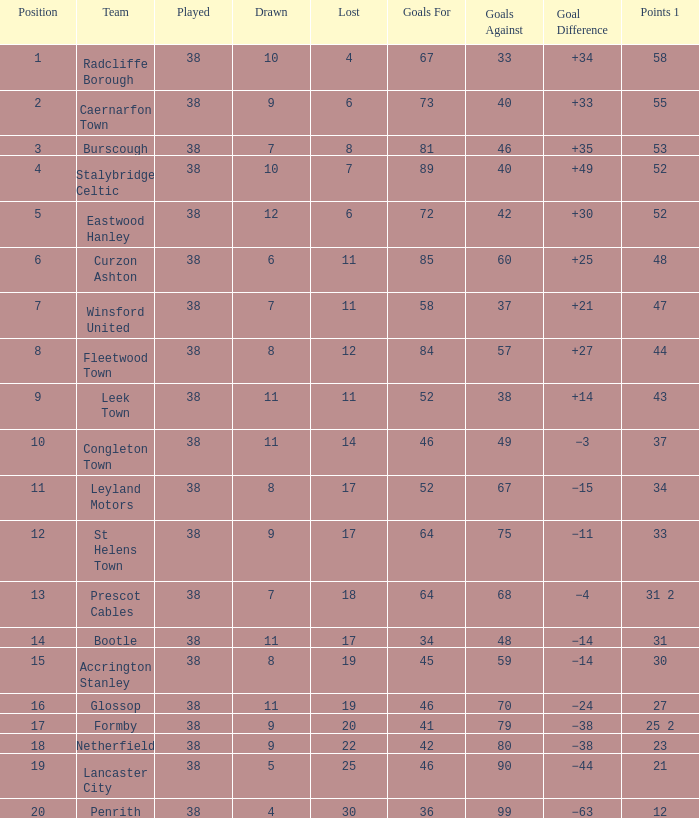Parse the full table. {'header': ['Position', 'Team', 'Played', 'Drawn', 'Lost', 'Goals For', 'Goals Against', 'Goal Difference', 'Points 1'], 'rows': [['1', 'Radcliffe Borough', '38', '10', '4', '67', '33', '+34', '58'], ['2', 'Caernarfon Town', '38', '9', '6', '73', '40', '+33', '55'], ['3', 'Burscough', '38', '7', '8', '81', '46', '+35', '53'], ['4', 'Stalybridge Celtic', '38', '10', '7', '89', '40', '+49', '52'], ['5', 'Eastwood Hanley', '38', '12', '6', '72', '42', '+30', '52'], ['6', 'Curzon Ashton', '38', '6', '11', '85', '60', '+25', '48'], ['7', 'Winsford United', '38', '7', '11', '58', '37', '+21', '47'], ['8', 'Fleetwood Town', '38', '8', '12', '84', '57', '+27', '44'], ['9', 'Leek Town', '38', '11', '11', '52', '38', '+14', '43'], ['10', 'Congleton Town', '38', '11', '14', '46', '49', '−3', '37'], ['11', 'Leyland Motors', '38', '8', '17', '52', '67', '−15', '34'], ['12', 'St Helens Town', '38', '9', '17', '64', '75', '−11', '33'], ['13', 'Prescot Cables', '38', '7', '18', '64', '68', '−4', '31 2'], ['14', 'Bootle', '38', '11', '17', '34', '48', '−14', '31'], ['15', 'Accrington Stanley', '38', '8', '19', '45', '59', '−14', '30'], ['16', 'Glossop', '38', '11', '19', '46', '70', '−24', '27'], ['17', 'Formby', '38', '9', '20', '41', '79', '−38', '25 2'], ['18', 'Netherfield', '38', '9', '22', '42', '80', '−38', '23'], ['19', 'Lancaster City', '38', '5', '25', '46', '90', '−44', '21'], ['20', 'Penrith', '38', '4', '30', '36', '99', '−63', '12']]} What is the missing with a drawn 11 for leek town? 11.0. 